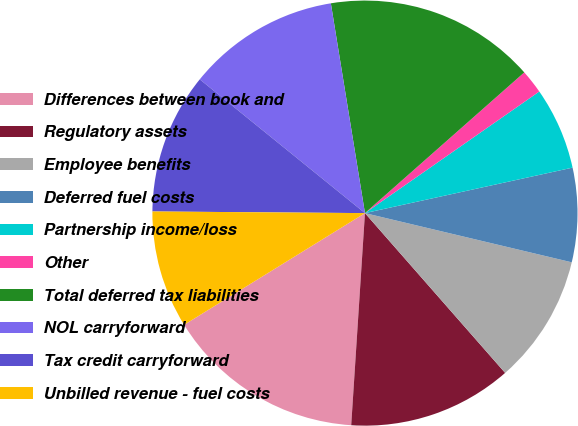<chart> <loc_0><loc_0><loc_500><loc_500><pie_chart><fcel>Differences between book and<fcel>Regulatory assets<fcel>Employee benefits<fcel>Deferred fuel costs<fcel>Partnership income/loss<fcel>Other<fcel>Total deferred tax liabilities<fcel>NOL carryforward<fcel>Tax credit carryforward<fcel>Unbilled revenue - fuel costs<nl><fcel>15.16%<fcel>12.49%<fcel>9.82%<fcel>7.15%<fcel>6.26%<fcel>1.82%<fcel>16.05%<fcel>11.6%<fcel>10.71%<fcel>8.93%<nl></chart> 